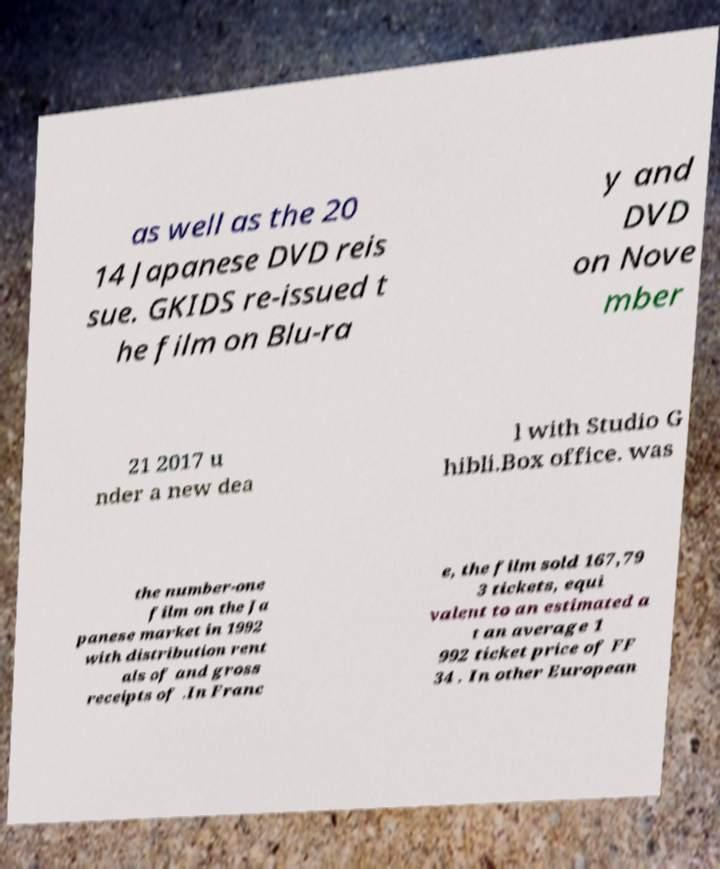Please read and relay the text visible in this image. What does it say? as well as the 20 14 Japanese DVD reis sue. GKIDS re-issued t he film on Blu-ra y and DVD on Nove mber 21 2017 u nder a new dea l with Studio G hibli.Box office. was the number-one film on the Ja panese market in 1992 with distribution rent als of and gross receipts of .In Franc e, the film sold 167,79 3 tickets, equi valent to an estimated a t an average 1 992 ticket price of FF 34 . In other European 